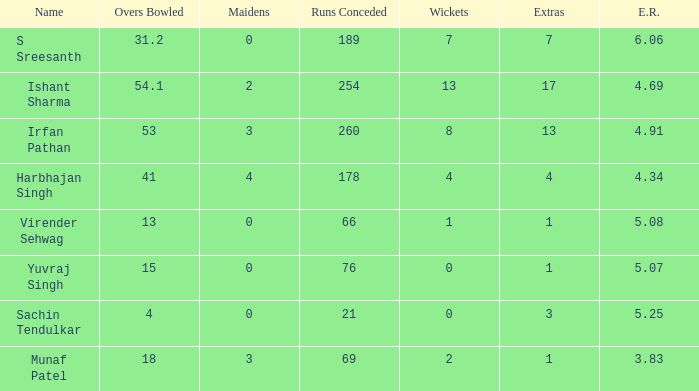Name the maaidens where overs bowled is 13 0.0. 